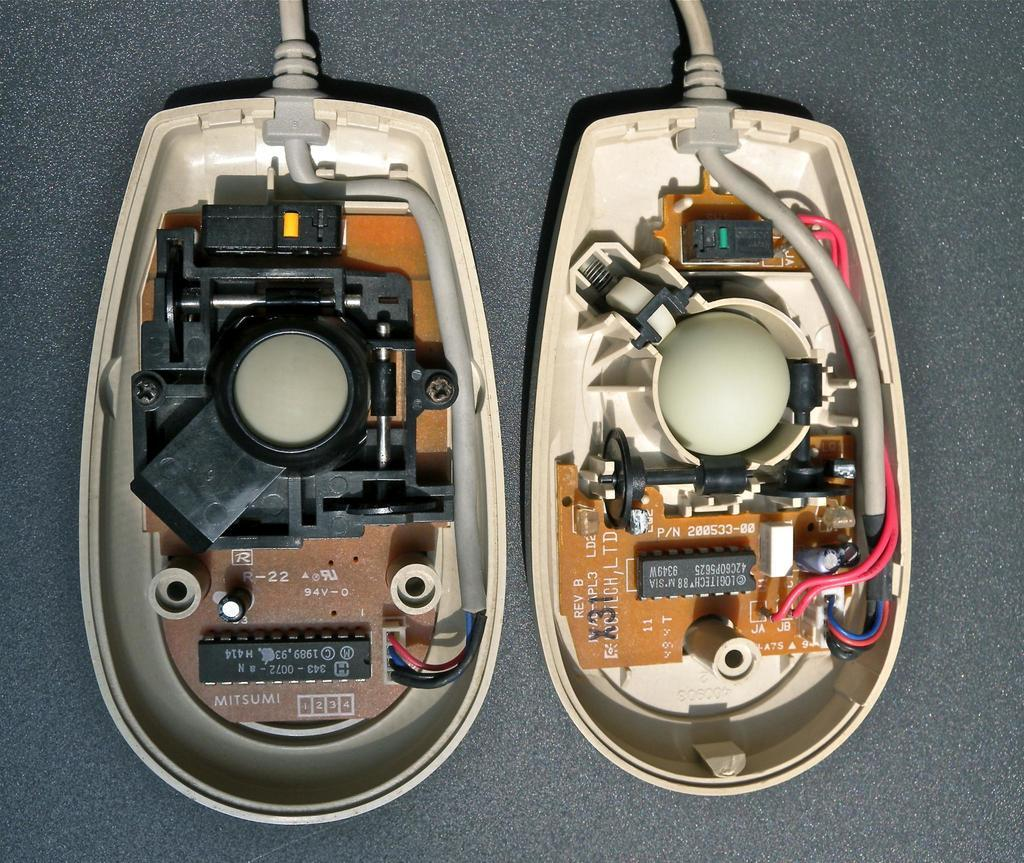What objects are present in the image? There are two mouse parts in the image. How are the mouse parts connected? The mouse parts are connected with wires. What type of hospital can be seen in the image? There is no hospital present in the image; it features two mouse parts connected with wires. 